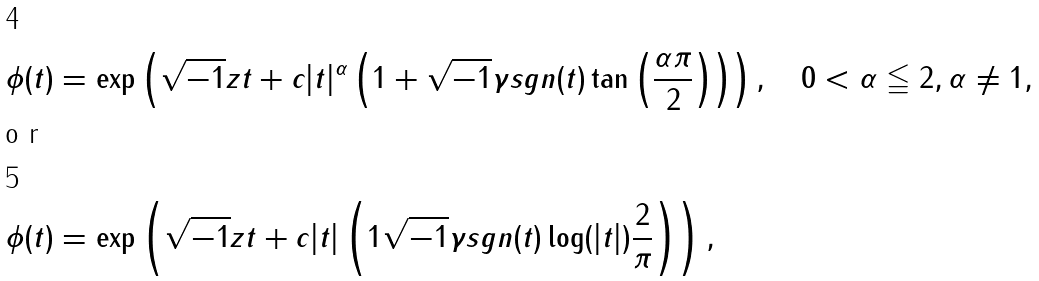Convert formula to latex. <formula><loc_0><loc_0><loc_500><loc_500>& \phi ( t ) = \exp \left ( \sqrt { - 1 } z t + c | t | ^ { \alpha } \left ( 1 + \sqrt { - 1 } \gamma s g n ( t ) \tan \left ( \frac { \alpha \pi } { 2 } \right ) \right ) \right ) , \quad 0 < \alpha \leqq 2 , \alpha \ne 1 , \\ \intertext { o r } & \phi ( t ) = \exp \left ( \sqrt { - 1 } z t + c | t | \left ( 1 \sqrt { - 1 } \gamma s g n ( t ) \log ( | t | ) \frac { 2 } { \pi } \right ) \right ) ,</formula> 